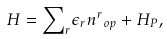Convert formula to latex. <formula><loc_0><loc_0><loc_500><loc_500>H = { { \sum } _ { r } } { { \epsilon } _ { r } } { { n ^ { r } } _ { o p } } + { H _ { P } } ,</formula> 